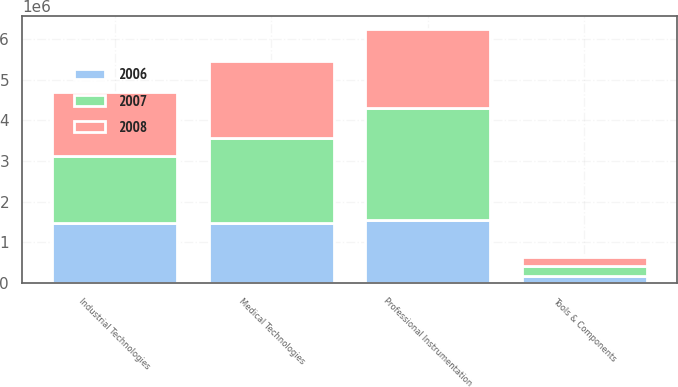Convert chart. <chart><loc_0><loc_0><loc_500><loc_500><stacked_bar_chart><ecel><fcel>Professional Instrumentation<fcel>Medical Technologies<fcel>Industrial Technologies<fcel>Tools & Components<nl><fcel>2007<fcel>2.75846e+06<fcel>2.1029e+06<fcel>1.65319e+06<fcel>246301<nl><fcel>2008<fcel>1.93551e+06<fcel>1.88452e+06<fcel>1.5798e+06<fcel>221914<nl><fcel>2006<fcel>1.54237e+06<fcel>1.46533e+06<fcel>1.46421e+06<fcel>182997<nl></chart> 